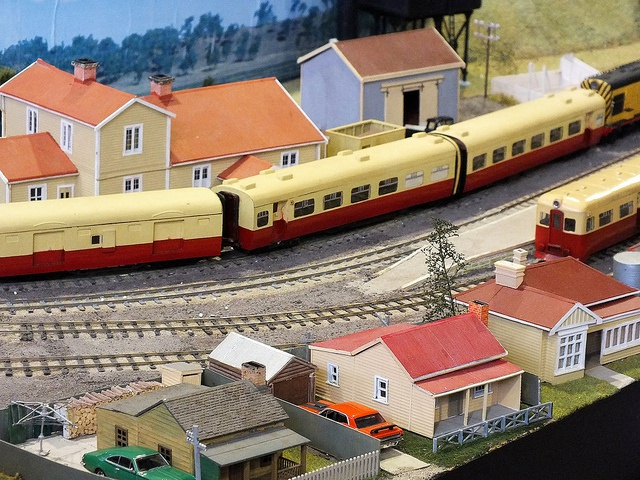Describe the objects in this image and their specific colors. I can see train in lightblue, khaki, maroon, tan, and black tones, car in lightblue, red, black, gray, and maroon tones, car in lightblue, black, darkgreen, and teal tones, and truck in lightblue, black, gray, darkgray, and khaki tones in this image. 